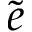Convert formula to latex. <formula><loc_0><loc_0><loc_500><loc_500>\tilde { e }</formula> 